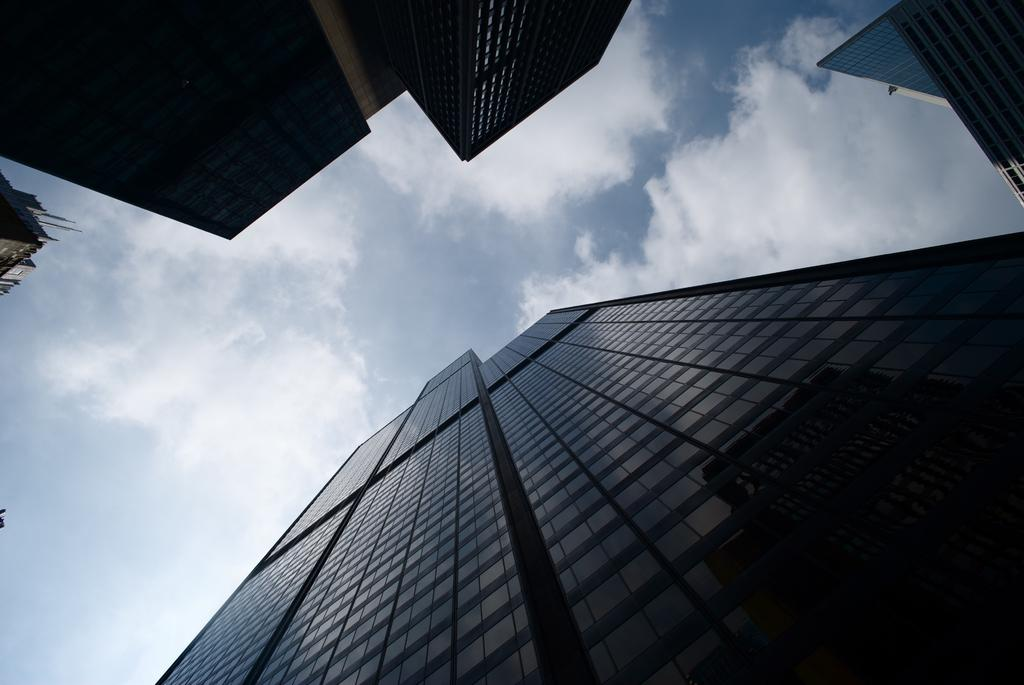What type of structures can be seen in the image? There are buildings in the image. What can be seen in the background of the image? The sky is visible in the background of the image. What is the condition of the sky in the image? Clouds are present in the sky. What type of sack is being used to expand the buildings in the image? There is no sack or expansion of buildings present in the image; it simply shows existing buildings and the sky. 